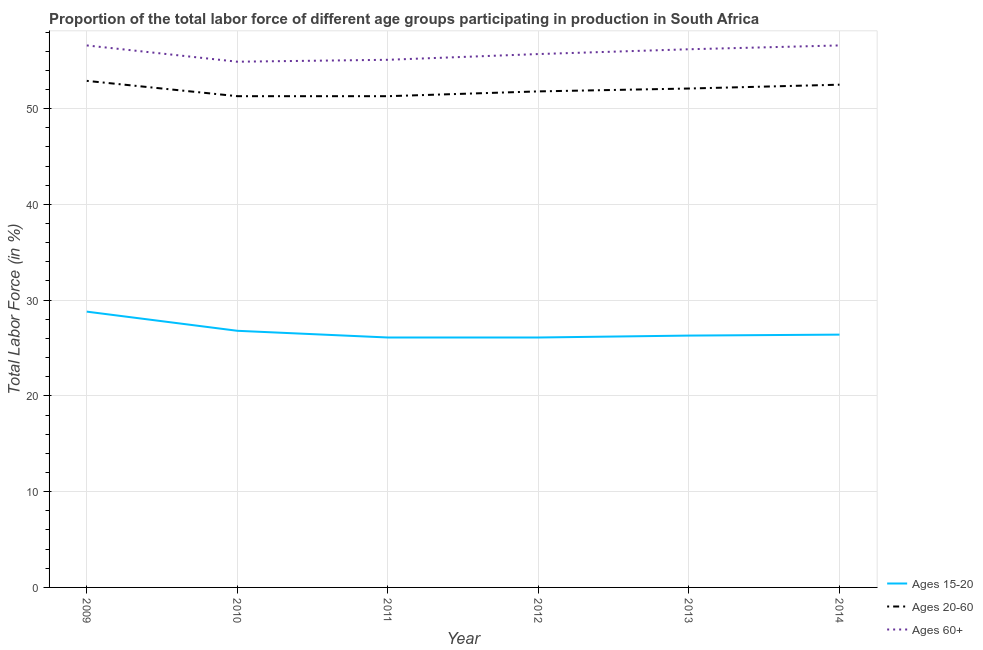How many different coloured lines are there?
Your answer should be very brief. 3. Does the line corresponding to percentage of labor force within the age group 15-20 intersect with the line corresponding to percentage of labor force above age 60?
Your answer should be very brief. No. What is the percentage of labor force within the age group 15-20 in 2012?
Your answer should be compact. 26.1. Across all years, what is the maximum percentage of labor force within the age group 15-20?
Ensure brevity in your answer.  28.8. Across all years, what is the minimum percentage of labor force above age 60?
Provide a succinct answer. 54.9. In which year was the percentage of labor force above age 60 maximum?
Offer a terse response. 2009. In which year was the percentage of labor force within the age group 20-60 minimum?
Keep it short and to the point. 2010. What is the total percentage of labor force within the age group 15-20 in the graph?
Your answer should be very brief. 160.5. What is the difference between the percentage of labor force above age 60 in 2012 and that in 2014?
Ensure brevity in your answer.  -0.9. What is the difference between the percentage of labor force within the age group 15-20 in 2010 and the percentage of labor force above age 60 in 2009?
Offer a very short reply. -29.8. What is the average percentage of labor force within the age group 20-60 per year?
Your answer should be compact. 51.98. In the year 2009, what is the difference between the percentage of labor force within the age group 15-20 and percentage of labor force above age 60?
Offer a very short reply. -27.8. In how many years, is the percentage of labor force within the age group 20-60 greater than 46 %?
Your response must be concise. 6. What is the ratio of the percentage of labor force within the age group 15-20 in 2011 to that in 2014?
Provide a short and direct response. 0.99. Is the percentage of labor force within the age group 20-60 in 2011 less than that in 2013?
Your answer should be very brief. Yes. What is the difference between the highest and the lowest percentage of labor force within the age group 20-60?
Your answer should be very brief. 1.6. In how many years, is the percentage of labor force within the age group 15-20 greater than the average percentage of labor force within the age group 15-20 taken over all years?
Your answer should be compact. 2. Is it the case that in every year, the sum of the percentage of labor force within the age group 15-20 and percentage of labor force within the age group 20-60 is greater than the percentage of labor force above age 60?
Give a very brief answer. Yes. Is the percentage of labor force within the age group 20-60 strictly less than the percentage of labor force within the age group 15-20 over the years?
Keep it short and to the point. No. How many lines are there?
Provide a succinct answer. 3. Does the graph contain grids?
Offer a very short reply. Yes. Where does the legend appear in the graph?
Your answer should be very brief. Bottom right. How are the legend labels stacked?
Keep it short and to the point. Vertical. What is the title of the graph?
Your answer should be very brief. Proportion of the total labor force of different age groups participating in production in South Africa. Does "Food" appear as one of the legend labels in the graph?
Your response must be concise. No. What is the label or title of the X-axis?
Provide a succinct answer. Year. What is the label or title of the Y-axis?
Keep it short and to the point. Total Labor Force (in %). What is the Total Labor Force (in %) of Ages 15-20 in 2009?
Offer a very short reply. 28.8. What is the Total Labor Force (in %) in Ages 20-60 in 2009?
Offer a terse response. 52.9. What is the Total Labor Force (in %) in Ages 60+ in 2009?
Make the answer very short. 56.6. What is the Total Labor Force (in %) of Ages 15-20 in 2010?
Your answer should be compact. 26.8. What is the Total Labor Force (in %) in Ages 20-60 in 2010?
Give a very brief answer. 51.3. What is the Total Labor Force (in %) of Ages 60+ in 2010?
Give a very brief answer. 54.9. What is the Total Labor Force (in %) in Ages 15-20 in 2011?
Offer a very short reply. 26.1. What is the Total Labor Force (in %) of Ages 20-60 in 2011?
Keep it short and to the point. 51.3. What is the Total Labor Force (in %) of Ages 60+ in 2011?
Offer a terse response. 55.1. What is the Total Labor Force (in %) in Ages 15-20 in 2012?
Your answer should be very brief. 26.1. What is the Total Labor Force (in %) in Ages 20-60 in 2012?
Keep it short and to the point. 51.8. What is the Total Labor Force (in %) in Ages 60+ in 2012?
Your answer should be very brief. 55.7. What is the Total Labor Force (in %) of Ages 15-20 in 2013?
Offer a terse response. 26.3. What is the Total Labor Force (in %) of Ages 20-60 in 2013?
Give a very brief answer. 52.1. What is the Total Labor Force (in %) of Ages 60+ in 2013?
Provide a short and direct response. 56.2. What is the Total Labor Force (in %) of Ages 15-20 in 2014?
Provide a short and direct response. 26.4. What is the Total Labor Force (in %) of Ages 20-60 in 2014?
Your answer should be compact. 52.5. What is the Total Labor Force (in %) in Ages 60+ in 2014?
Your answer should be compact. 56.6. Across all years, what is the maximum Total Labor Force (in %) of Ages 15-20?
Keep it short and to the point. 28.8. Across all years, what is the maximum Total Labor Force (in %) in Ages 20-60?
Offer a very short reply. 52.9. Across all years, what is the maximum Total Labor Force (in %) in Ages 60+?
Your answer should be compact. 56.6. Across all years, what is the minimum Total Labor Force (in %) in Ages 15-20?
Your answer should be compact. 26.1. Across all years, what is the minimum Total Labor Force (in %) of Ages 20-60?
Ensure brevity in your answer.  51.3. Across all years, what is the minimum Total Labor Force (in %) in Ages 60+?
Provide a short and direct response. 54.9. What is the total Total Labor Force (in %) in Ages 15-20 in the graph?
Provide a succinct answer. 160.5. What is the total Total Labor Force (in %) in Ages 20-60 in the graph?
Your answer should be compact. 311.9. What is the total Total Labor Force (in %) in Ages 60+ in the graph?
Your answer should be compact. 335.1. What is the difference between the Total Labor Force (in %) of Ages 15-20 in 2009 and that in 2010?
Provide a short and direct response. 2. What is the difference between the Total Labor Force (in %) in Ages 20-60 in 2009 and that in 2010?
Your answer should be compact. 1.6. What is the difference between the Total Labor Force (in %) of Ages 60+ in 2009 and that in 2010?
Provide a short and direct response. 1.7. What is the difference between the Total Labor Force (in %) of Ages 15-20 in 2009 and that in 2012?
Your answer should be very brief. 2.7. What is the difference between the Total Labor Force (in %) in Ages 60+ in 2009 and that in 2012?
Your response must be concise. 0.9. What is the difference between the Total Labor Force (in %) of Ages 60+ in 2009 and that in 2013?
Your answer should be compact. 0.4. What is the difference between the Total Labor Force (in %) of Ages 20-60 in 2009 and that in 2014?
Make the answer very short. 0.4. What is the difference between the Total Labor Force (in %) of Ages 20-60 in 2010 and that in 2011?
Provide a short and direct response. 0. What is the difference between the Total Labor Force (in %) in Ages 15-20 in 2010 and that in 2013?
Your answer should be very brief. 0.5. What is the difference between the Total Labor Force (in %) of Ages 20-60 in 2010 and that in 2013?
Offer a terse response. -0.8. What is the difference between the Total Labor Force (in %) of Ages 15-20 in 2010 and that in 2014?
Keep it short and to the point. 0.4. What is the difference between the Total Labor Force (in %) in Ages 20-60 in 2010 and that in 2014?
Your answer should be very brief. -1.2. What is the difference between the Total Labor Force (in %) of Ages 60+ in 2011 and that in 2012?
Ensure brevity in your answer.  -0.6. What is the difference between the Total Labor Force (in %) in Ages 15-20 in 2011 and that in 2013?
Your answer should be very brief. -0.2. What is the difference between the Total Labor Force (in %) in Ages 20-60 in 2011 and that in 2013?
Provide a short and direct response. -0.8. What is the difference between the Total Labor Force (in %) in Ages 20-60 in 2011 and that in 2014?
Your response must be concise. -1.2. What is the difference between the Total Labor Force (in %) in Ages 60+ in 2011 and that in 2014?
Give a very brief answer. -1.5. What is the difference between the Total Labor Force (in %) of Ages 15-20 in 2012 and that in 2013?
Keep it short and to the point. -0.2. What is the difference between the Total Labor Force (in %) of Ages 60+ in 2012 and that in 2013?
Offer a terse response. -0.5. What is the difference between the Total Labor Force (in %) of Ages 15-20 in 2012 and that in 2014?
Provide a short and direct response. -0.3. What is the difference between the Total Labor Force (in %) of Ages 20-60 in 2012 and that in 2014?
Your response must be concise. -0.7. What is the difference between the Total Labor Force (in %) in Ages 15-20 in 2013 and that in 2014?
Ensure brevity in your answer.  -0.1. What is the difference between the Total Labor Force (in %) of Ages 15-20 in 2009 and the Total Labor Force (in %) of Ages 20-60 in 2010?
Provide a succinct answer. -22.5. What is the difference between the Total Labor Force (in %) in Ages 15-20 in 2009 and the Total Labor Force (in %) in Ages 60+ in 2010?
Give a very brief answer. -26.1. What is the difference between the Total Labor Force (in %) in Ages 15-20 in 2009 and the Total Labor Force (in %) in Ages 20-60 in 2011?
Make the answer very short. -22.5. What is the difference between the Total Labor Force (in %) of Ages 15-20 in 2009 and the Total Labor Force (in %) of Ages 60+ in 2011?
Your response must be concise. -26.3. What is the difference between the Total Labor Force (in %) of Ages 20-60 in 2009 and the Total Labor Force (in %) of Ages 60+ in 2011?
Give a very brief answer. -2.2. What is the difference between the Total Labor Force (in %) in Ages 15-20 in 2009 and the Total Labor Force (in %) in Ages 60+ in 2012?
Keep it short and to the point. -26.9. What is the difference between the Total Labor Force (in %) of Ages 15-20 in 2009 and the Total Labor Force (in %) of Ages 20-60 in 2013?
Make the answer very short. -23.3. What is the difference between the Total Labor Force (in %) of Ages 15-20 in 2009 and the Total Labor Force (in %) of Ages 60+ in 2013?
Make the answer very short. -27.4. What is the difference between the Total Labor Force (in %) of Ages 15-20 in 2009 and the Total Labor Force (in %) of Ages 20-60 in 2014?
Your answer should be compact. -23.7. What is the difference between the Total Labor Force (in %) in Ages 15-20 in 2009 and the Total Labor Force (in %) in Ages 60+ in 2014?
Keep it short and to the point. -27.8. What is the difference between the Total Labor Force (in %) in Ages 15-20 in 2010 and the Total Labor Force (in %) in Ages 20-60 in 2011?
Make the answer very short. -24.5. What is the difference between the Total Labor Force (in %) in Ages 15-20 in 2010 and the Total Labor Force (in %) in Ages 60+ in 2011?
Ensure brevity in your answer.  -28.3. What is the difference between the Total Labor Force (in %) of Ages 20-60 in 2010 and the Total Labor Force (in %) of Ages 60+ in 2011?
Offer a very short reply. -3.8. What is the difference between the Total Labor Force (in %) in Ages 15-20 in 2010 and the Total Labor Force (in %) in Ages 60+ in 2012?
Offer a very short reply. -28.9. What is the difference between the Total Labor Force (in %) of Ages 15-20 in 2010 and the Total Labor Force (in %) of Ages 20-60 in 2013?
Offer a very short reply. -25.3. What is the difference between the Total Labor Force (in %) of Ages 15-20 in 2010 and the Total Labor Force (in %) of Ages 60+ in 2013?
Provide a short and direct response. -29.4. What is the difference between the Total Labor Force (in %) of Ages 20-60 in 2010 and the Total Labor Force (in %) of Ages 60+ in 2013?
Provide a succinct answer. -4.9. What is the difference between the Total Labor Force (in %) in Ages 15-20 in 2010 and the Total Labor Force (in %) in Ages 20-60 in 2014?
Ensure brevity in your answer.  -25.7. What is the difference between the Total Labor Force (in %) of Ages 15-20 in 2010 and the Total Labor Force (in %) of Ages 60+ in 2014?
Give a very brief answer. -29.8. What is the difference between the Total Labor Force (in %) in Ages 15-20 in 2011 and the Total Labor Force (in %) in Ages 20-60 in 2012?
Offer a very short reply. -25.7. What is the difference between the Total Labor Force (in %) of Ages 15-20 in 2011 and the Total Labor Force (in %) of Ages 60+ in 2012?
Provide a succinct answer. -29.6. What is the difference between the Total Labor Force (in %) in Ages 15-20 in 2011 and the Total Labor Force (in %) in Ages 60+ in 2013?
Your answer should be compact. -30.1. What is the difference between the Total Labor Force (in %) in Ages 15-20 in 2011 and the Total Labor Force (in %) in Ages 20-60 in 2014?
Offer a terse response. -26.4. What is the difference between the Total Labor Force (in %) in Ages 15-20 in 2011 and the Total Labor Force (in %) in Ages 60+ in 2014?
Offer a very short reply. -30.5. What is the difference between the Total Labor Force (in %) of Ages 15-20 in 2012 and the Total Labor Force (in %) of Ages 60+ in 2013?
Your response must be concise. -30.1. What is the difference between the Total Labor Force (in %) of Ages 20-60 in 2012 and the Total Labor Force (in %) of Ages 60+ in 2013?
Make the answer very short. -4.4. What is the difference between the Total Labor Force (in %) in Ages 15-20 in 2012 and the Total Labor Force (in %) in Ages 20-60 in 2014?
Provide a succinct answer. -26.4. What is the difference between the Total Labor Force (in %) in Ages 15-20 in 2012 and the Total Labor Force (in %) in Ages 60+ in 2014?
Keep it short and to the point. -30.5. What is the difference between the Total Labor Force (in %) of Ages 15-20 in 2013 and the Total Labor Force (in %) of Ages 20-60 in 2014?
Offer a very short reply. -26.2. What is the difference between the Total Labor Force (in %) of Ages 15-20 in 2013 and the Total Labor Force (in %) of Ages 60+ in 2014?
Offer a terse response. -30.3. What is the difference between the Total Labor Force (in %) in Ages 20-60 in 2013 and the Total Labor Force (in %) in Ages 60+ in 2014?
Offer a very short reply. -4.5. What is the average Total Labor Force (in %) of Ages 15-20 per year?
Your answer should be very brief. 26.75. What is the average Total Labor Force (in %) of Ages 20-60 per year?
Your answer should be compact. 51.98. What is the average Total Labor Force (in %) of Ages 60+ per year?
Make the answer very short. 55.85. In the year 2009, what is the difference between the Total Labor Force (in %) in Ages 15-20 and Total Labor Force (in %) in Ages 20-60?
Your answer should be very brief. -24.1. In the year 2009, what is the difference between the Total Labor Force (in %) of Ages 15-20 and Total Labor Force (in %) of Ages 60+?
Make the answer very short. -27.8. In the year 2009, what is the difference between the Total Labor Force (in %) in Ages 20-60 and Total Labor Force (in %) in Ages 60+?
Offer a very short reply. -3.7. In the year 2010, what is the difference between the Total Labor Force (in %) of Ages 15-20 and Total Labor Force (in %) of Ages 20-60?
Offer a very short reply. -24.5. In the year 2010, what is the difference between the Total Labor Force (in %) in Ages 15-20 and Total Labor Force (in %) in Ages 60+?
Your answer should be compact. -28.1. In the year 2010, what is the difference between the Total Labor Force (in %) in Ages 20-60 and Total Labor Force (in %) in Ages 60+?
Provide a short and direct response. -3.6. In the year 2011, what is the difference between the Total Labor Force (in %) in Ages 15-20 and Total Labor Force (in %) in Ages 20-60?
Offer a terse response. -25.2. In the year 2012, what is the difference between the Total Labor Force (in %) in Ages 15-20 and Total Labor Force (in %) in Ages 20-60?
Provide a short and direct response. -25.7. In the year 2012, what is the difference between the Total Labor Force (in %) of Ages 15-20 and Total Labor Force (in %) of Ages 60+?
Your answer should be very brief. -29.6. In the year 2012, what is the difference between the Total Labor Force (in %) of Ages 20-60 and Total Labor Force (in %) of Ages 60+?
Ensure brevity in your answer.  -3.9. In the year 2013, what is the difference between the Total Labor Force (in %) of Ages 15-20 and Total Labor Force (in %) of Ages 20-60?
Your answer should be compact. -25.8. In the year 2013, what is the difference between the Total Labor Force (in %) of Ages 15-20 and Total Labor Force (in %) of Ages 60+?
Make the answer very short. -29.9. In the year 2014, what is the difference between the Total Labor Force (in %) of Ages 15-20 and Total Labor Force (in %) of Ages 20-60?
Give a very brief answer. -26.1. In the year 2014, what is the difference between the Total Labor Force (in %) of Ages 15-20 and Total Labor Force (in %) of Ages 60+?
Make the answer very short. -30.2. What is the ratio of the Total Labor Force (in %) in Ages 15-20 in 2009 to that in 2010?
Offer a terse response. 1.07. What is the ratio of the Total Labor Force (in %) in Ages 20-60 in 2009 to that in 2010?
Keep it short and to the point. 1.03. What is the ratio of the Total Labor Force (in %) of Ages 60+ in 2009 to that in 2010?
Provide a succinct answer. 1.03. What is the ratio of the Total Labor Force (in %) in Ages 15-20 in 2009 to that in 2011?
Offer a very short reply. 1.1. What is the ratio of the Total Labor Force (in %) in Ages 20-60 in 2009 to that in 2011?
Make the answer very short. 1.03. What is the ratio of the Total Labor Force (in %) of Ages 60+ in 2009 to that in 2011?
Give a very brief answer. 1.03. What is the ratio of the Total Labor Force (in %) of Ages 15-20 in 2009 to that in 2012?
Make the answer very short. 1.1. What is the ratio of the Total Labor Force (in %) in Ages 20-60 in 2009 to that in 2012?
Your answer should be compact. 1.02. What is the ratio of the Total Labor Force (in %) in Ages 60+ in 2009 to that in 2012?
Offer a terse response. 1.02. What is the ratio of the Total Labor Force (in %) of Ages 15-20 in 2009 to that in 2013?
Your response must be concise. 1.1. What is the ratio of the Total Labor Force (in %) of Ages 20-60 in 2009 to that in 2013?
Provide a short and direct response. 1.02. What is the ratio of the Total Labor Force (in %) of Ages 60+ in 2009 to that in 2013?
Your answer should be very brief. 1.01. What is the ratio of the Total Labor Force (in %) in Ages 20-60 in 2009 to that in 2014?
Provide a succinct answer. 1.01. What is the ratio of the Total Labor Force (in %) of Ages 15-20 in 2010 to that in 2011?
Provide a succinct answer. 1.03. What is the ratio of the Total Labor Force (in %) of Ages 60+ in 2010 to that in 2011?
Provide a succinct answer. 1. What is the ratio of the Total Labor Force (in %) of Ages 15-20 in 2010 to that in 2012?
Provide a succinct answer. 1.03. What is the ratio of the Total Labor Force (in %) in Ages 20-60 in 2010 to that in 2012?
Your answer should be very brief. 0.99. What is the ratio of the Total Labor Force (in %) of Ages 60+ in 2010 to that in 2012?
Your response must be concise. 0.99. What is the ratio of the Total Labor Force (in %) of Ages 15-20 in 2010 to that in 2013?
Your answer should be compact. 1.02. What is the ratio of the Total Labor Force (in %) of Ages 20-60 in 2010 to that in 2013?
Provide a succinct answer. 0.98. What is the ratio of the Total Labor Force (in %) of Ages 60+ in 2010 to that in 2013?
Your answer should be compact. 0.98. What is the ratio of the Total Labor Force (in %) of Ages 15-20 in 2010 to that in 2014?
Provide a short and direct response. 1.02. What is the ratio of the Total Labor Force (in %) of Ages 20-60 in 2010 to that in 2014?
Your response must be concise. 0.98. What is the ratio of the Total Labor Force (in %) of Ages 60+ in 2010 to that in 2014?
Provide a short and direct response. 0.97. What is the ratio of the Total Labor Force (in %) in Ages 15-20 in 2011 to that in 2012?
Your answer should be very brief. 1. What is the ratio of the Total Labor Force (in %) in Ages 20-60 in 2011 to that in 2012?
Make the answer very short. 0.99. What is the ratio of the Total Labor Force (in %) of Ages 15-20 in 2011 to that in 2013?
Make the answer very short. 0.99. What is the ratio of the Total Labor Force (in %) in Ages 20-60 in 2011 to that in 2013?
Provide a short and direct response. 0.98. What is the ratio of the Total Labor Force (in %) of Ages 60+ in 2011 to that in 2013?
Provide a short and direct response. 0.98. What is the ratio of the Total Labor Force (in %) in Ages 15-20 in 2011 to that in 2014?
Your answer should be very brief. 0.99. What is the ratio of the Total Labor Force (in %) of Ages 20-60 in 2011 to that in 2014?
Provide a succinct answer. 0.98. What is the ratio of the Total Labor Force (in %) of Ages 60+ in 2011 to that in 2014?
Offer a very short reply. 0.97. What is the ratio of the Total Labor Force (in %) of Ages 15-20 in 2012 to that in 2013?
Your answer should be very brief. 0.99. What is the ratio of the Total Labor Force (in %) in Ages 20-60 in 2012 to that in 2013?
Provide a short and direct response. 0.99. What is the ratio of the Total Labor Force (in %) of Ages 15-20 in 2012 to that in 2014?
Offer a terse response. 0.99. What is the ratio of the Total Labor Force (in %) of Ages 20-60 in 2012 to that in 2014?
Provide a succinct answer. 0.99. What is the ratio of the Total Labor Force (in %) of Ages 60+ in 2012 to that in 2014?
Ensure brevity in your answer.  0.98. What is the difference between the highest and the second highest Total Labor Force (in %) of Ages 15-20?
Your answer should be compact. 2. What is the difference between the highest and the lowest Total Labor Force (in %) in Ages 15-20?
Offer a very short reply. 2.7. What is the difference between the highest and the lowest Total Labor Force (in %) of Ages 60+?
Offer a very short reply. 1.7. 